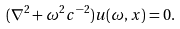Convert formula to latex. <formula><loc_0><loc_0><loc_500><loc_500>( \nabla ^ { 2 } + \omega ^ { 2 } c ^ { - 2 } ) u ( \omega , x ) = 0 .</formula> 